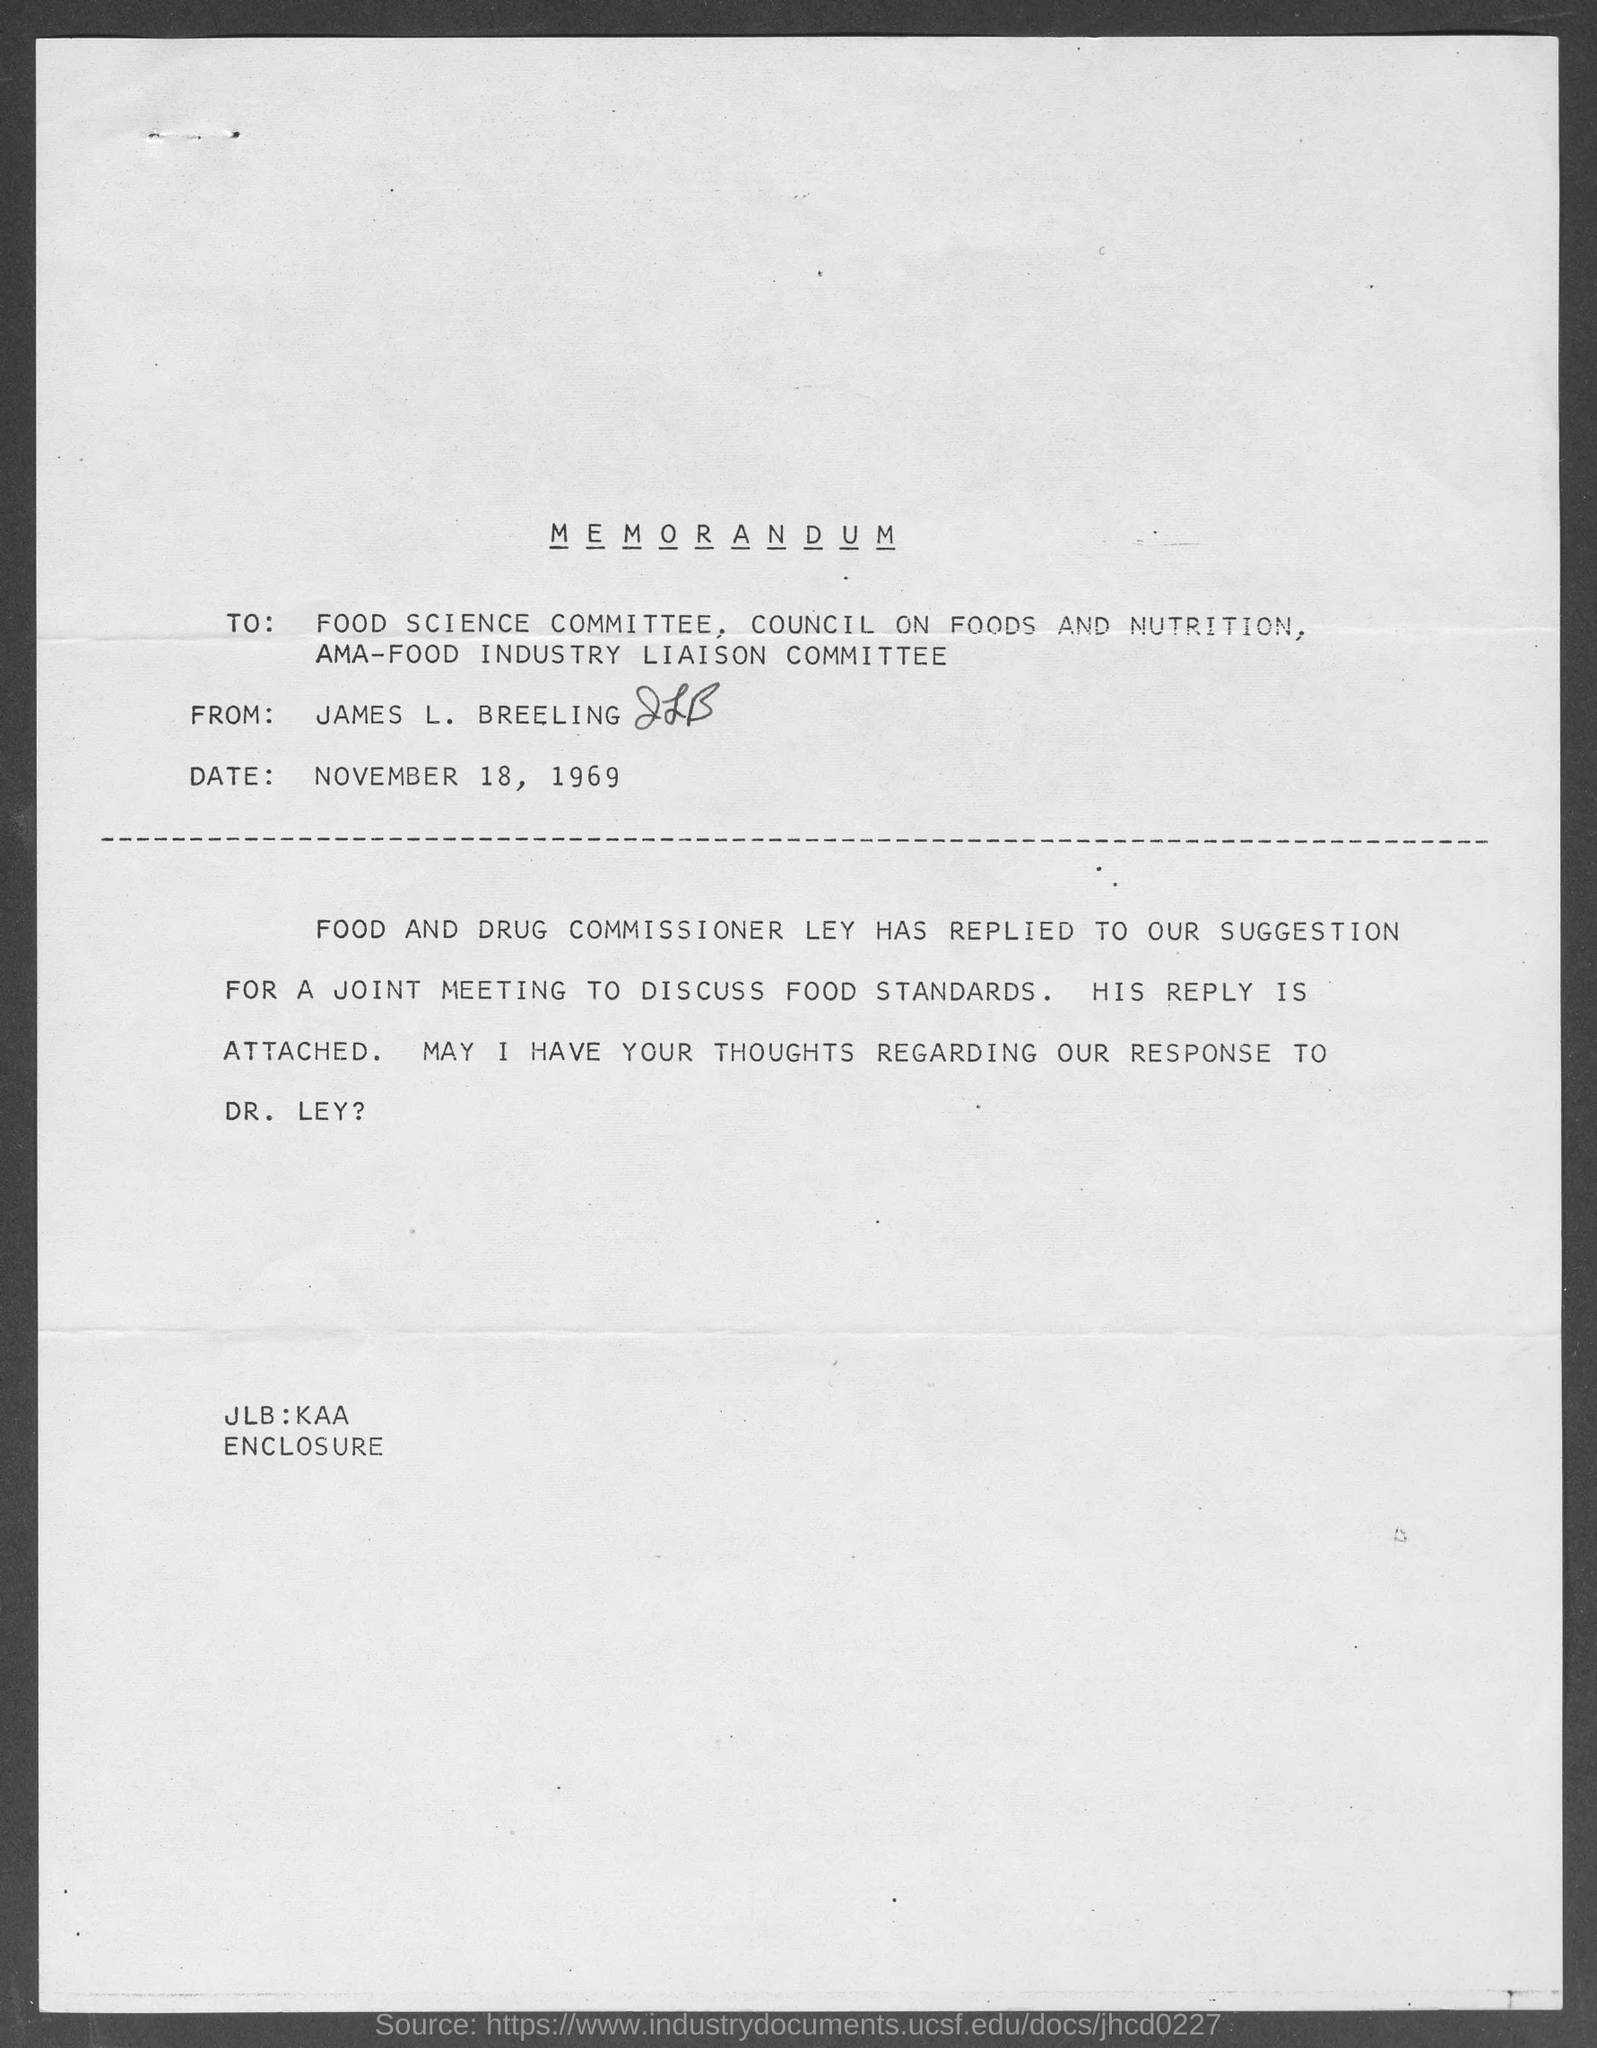When is the memorandum dated?
Your response must be concise. November 18, 1969. What is the from address in memorandum ?
Keep it short and to the point. James L. Breeling. 